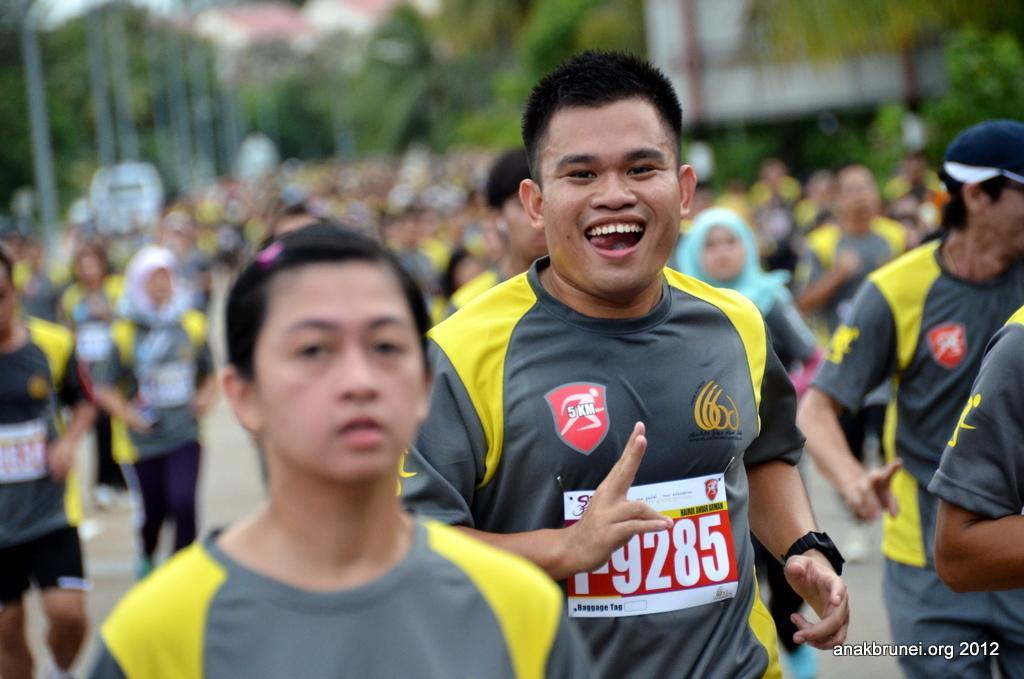Please provide a concise description of this image. In this picture I can see there are many people running here and they are wearing jerseys. The person here is laughing and in the backdrop there are trees, poles and buildings. 